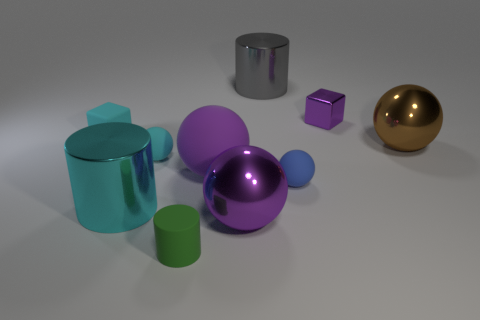Subtract all brown balls. How many balls are left? 4 Subtract all big matte balls. How many balls are left? 4 Subtract all gray balls. Subtract all red blocks. How many balls are left? 5 Subtract all cubes. How many objects are left? 8 Subtract all cyan blocks. Subtract all metallic things. How many objects are left? 4 Add 4 big brown metal spheres. How many big brown metal spheres are left? 5 Add 5 gray matte cylinders. How many gray matte cylinders exist? 5 Subtract 0 red blocks. How many objects are left? 10 